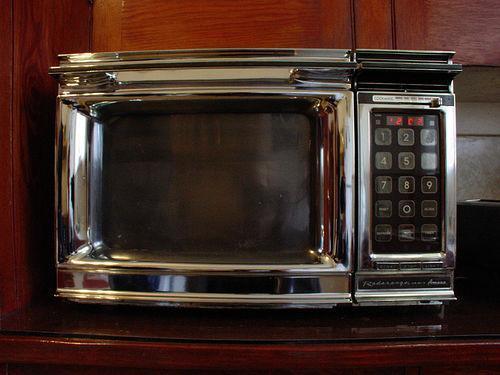How many buttons are on the microwave?
Give a very brief answer. 15. 